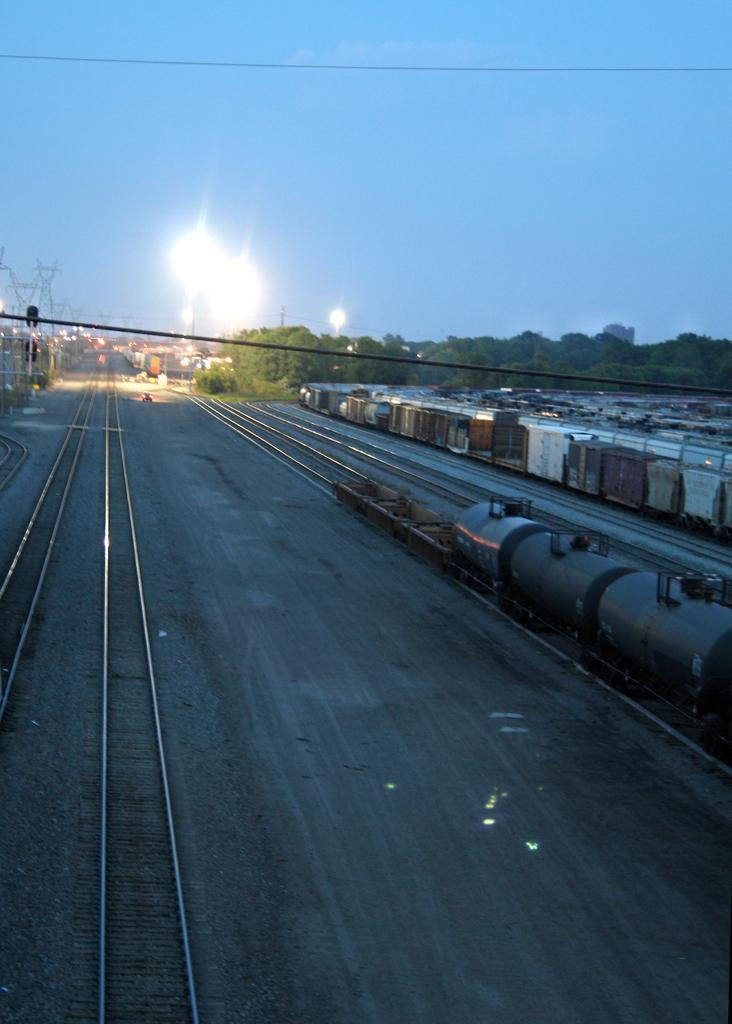What can be seen on the ground in the image? There are tracks in the image. What is on the tracks in the image? There are locomotives on the tracks. What is visible behind the locomotives in the image? There are trees and poles behind the locomotives. What is visible at the top of the image? The sky is visible at the top of the image. What type of battle is taking place in the image? There is no battle present in the image; it features tracks, locomotives, trees, poles, and the sky. What is the topic of the discussion happening between the trees and poles in the image? There is no discussion happening between the trees and poles in the image; they are stationary objects. 